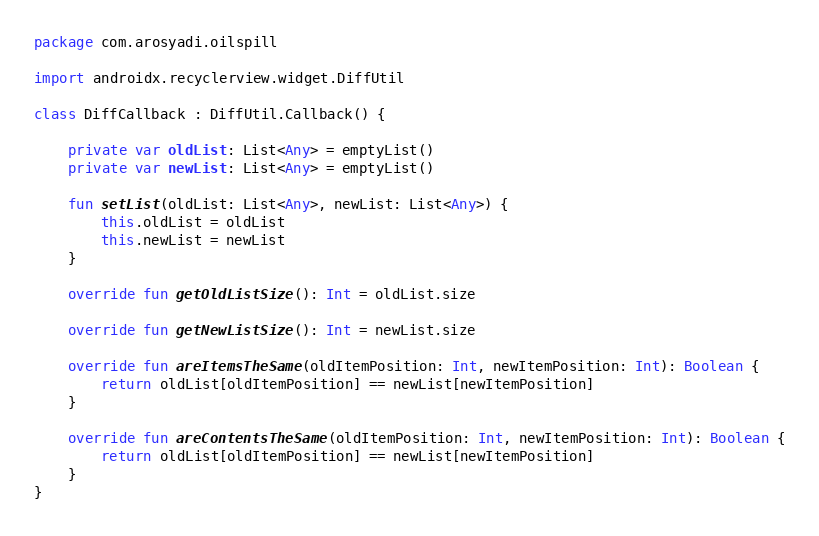Convert code to text. <code><loc_0><loc_0><loc_500><loc_500><_Kotlin_>package com.arosyadi.oilspill

import androidx.recyclerview.widget.DiffUtil

class DiffCallback : DiffUtil.Callback() {

    private var oldList: List<Any> = emptyList()
    private var newList: List<Any> = emptyList()

    fun setList(oldList: List<Any>, newList: List<Any>) {
        this.oldList = oldList
        this.newList = newList
    }

    override fun getOldListSize(): Int = oldList.size

    override fun getNewListSize(): Int = newList.size

    override fun areItemsTheSame(oldItemPosition: Int, newItemPosition: Int): Boolean {
        return oldList[oldItemPosition] == newList[newItemPosition]
    }

    override fun areContentsTheSame(oldItemPosition: Int, newItemPosition: Int): Boolean {
        return oldList[oldItemPosition] == newList[newItemPosition]
    }
}</code> 